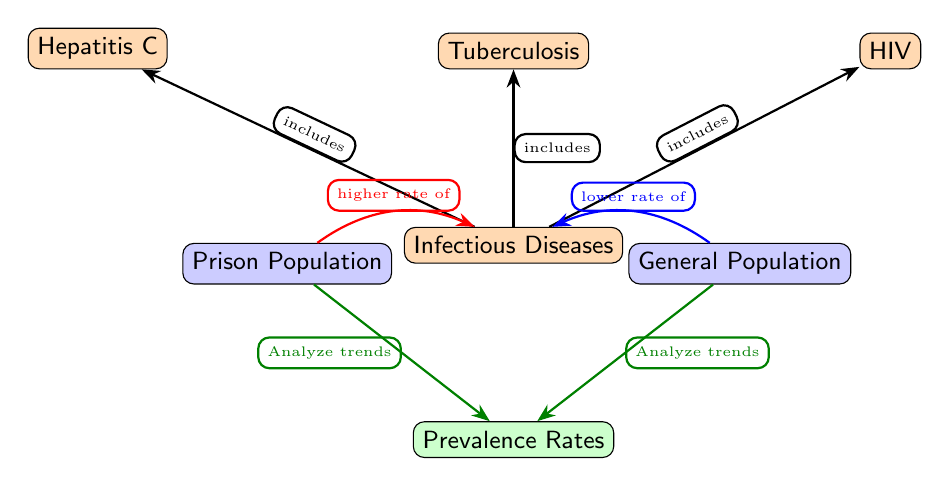What populations are compared in the diagram? The diagram visually presents two primary populations: "Prison Population" and "General Population," as labeled nodes at the top.
Answer: Prison Population, General Population Which diseases are included under infectious diseases? The diagram lists three specific diseases branching from the "Infectious Diseases" node: "Hepatitis C," "Tuberculosis," and "HIV."
Answer: Hepatitis C, Tuberculosis, HIV What is the trend for imprisonment populations regarding infectious diseases? The arrow from "Prison Population" to "Infectious Diseases" indicates a "higher rate of" infectious diseases in prison populations. This is visually linked by the arrow indicating the prevalence rate analysis direction.
Answer: Higher rate How do the infectious disease rates in the general population compare to the prison population? The flow from "General Population" to "Infectious Diseases" shows a "lower rate of" infectious diseases compared to the prison population, which indicates a contrasting trend.
Answer: Lower rate What analytical action is suggested for both populations? The diagram shows arrows labeled "Analyze trends" from both "Prison Population" and "General Population" directed towards "Prevalence Rates," indicating the suggested action for both populations.
Answer: Analyze trends What is the relationship between the prevalence rates and the populations? The diagram depicts two arrows directed from both populations ("Prison Population" and "General Population") to "Prevalence Rates," indicating that the rates are derived from analyzing the data of both populations.
Answer: Analyze data How many diseases are included in the diagram? The node "Infectious Diseases" branches into three diseases, as shown by the lines connecting each disease node to the central disease node. This indicates a count of the diseases mentioned.
Answer: Three What color is used to represent the prison population? The "Prison Population" node is filled with a blue shade, clearly differentiating it from other nodes based on the color coding used in the diagram.
Answer: Blue What does the red arrow symbolize in the diagram? The red arrow from "Prison Population" to "Infectious Diseases" denotes a relationship indicating the higher prevalence of infectious diseases specifically within the prison population.
Answer: Higher rate of infectious diseases 